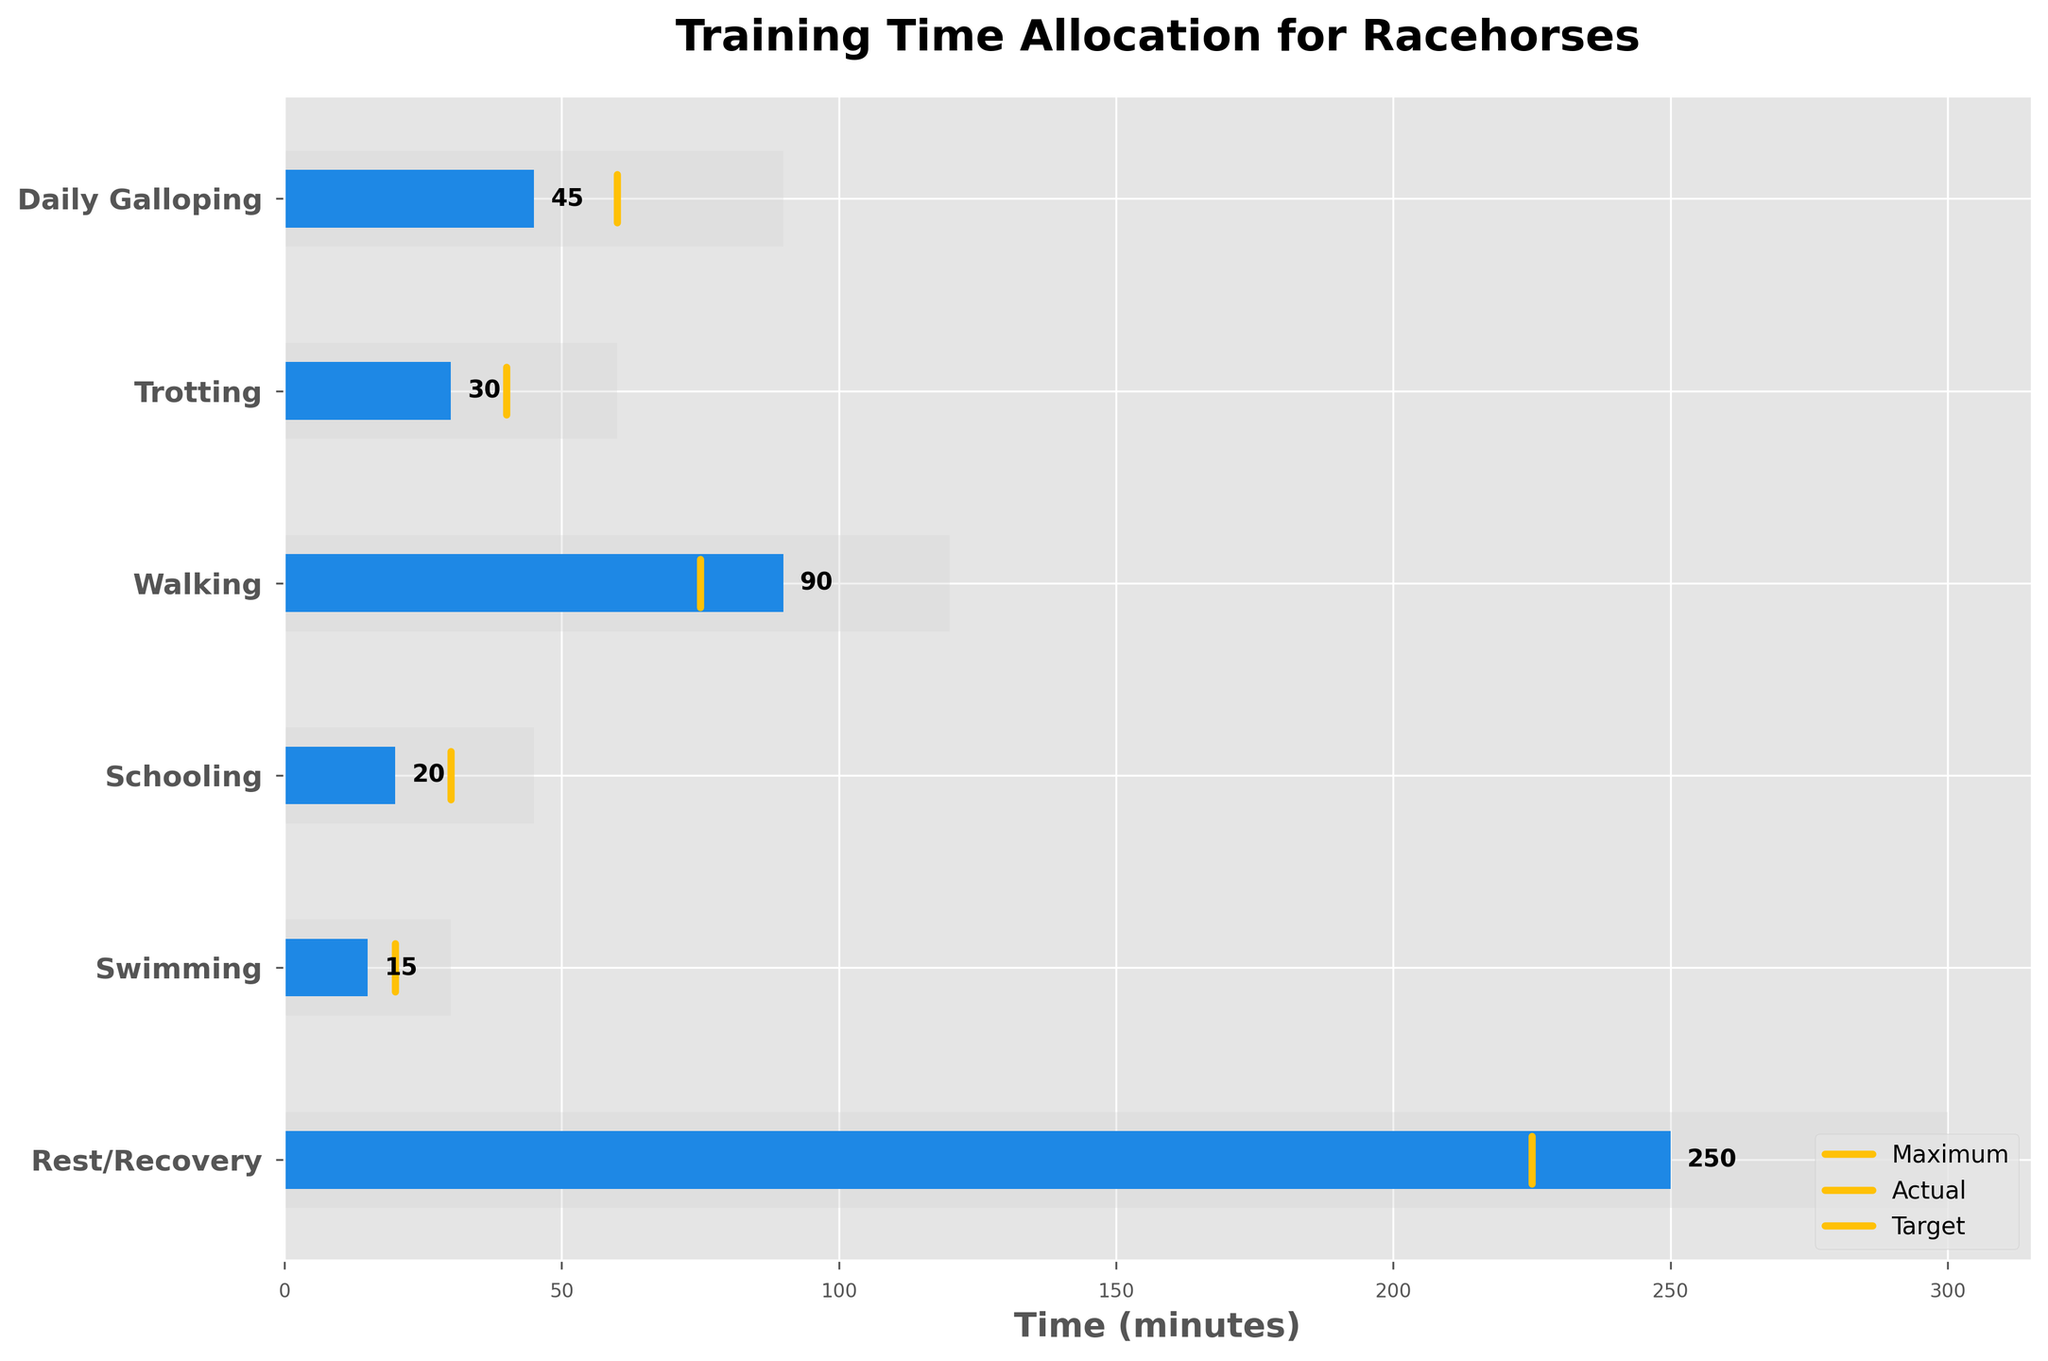What's the title of the plot? The title of the plot is prominently displayed at the top of the chart, which indicates the main subject of the data being visualized.
Answer: Training Time Allocation for Racehorses Which activity has the highest actual training time? By examining the bars representing actual training times, we identify the activity with the longest bar.
Answer: Rest/Recovery What is the target time for walking? Locate the vertical target line for walking and read the value at the base of the plot.
Answer: 75 minutes Which activities have actual training times that are below their target times? Compare the lengths of the actual training time bars against their corresponding target lines.
Answer: Daily Galloping, Trotting, Schooling, Swimming What's the difference between the target and actual training time for schooling? Subtract the actual training time of schooling from its target training time: 30 - 20.
Answer: 10 minutes Is there any activity where the actual training time exceeds the maximum allotted time? Observe if any actual training time bars extend beyond their corresponding maximum background bars.
Answer: No Which activity has the largest gap between maximum and actual training time? Calculate the difference between the maximum and actual times for each activity and identify the largest difference. For example, Rest/Recovery: 300 - 250, Walking: 120 - 90, etc.
Answer: Walking How many activities have a target training time of more than 50 minutes? Count the number of target training times that exceed 50 minutes by examining the target lines.
Answer: 2 activities (Daily Galloping and Rest/Recovery) What percentage of the maximum time is allocated to actual time for trotting? Divide the actual time by the maximum time for trotting and multiply by 100: (30 / 60) * 100.
Answer: 50% If you sum up all actual training times, what is the total? Add together all the actual training times: 45 + 30 + 90 + 20 + 15 + 250.
Answer: 450 minutes 